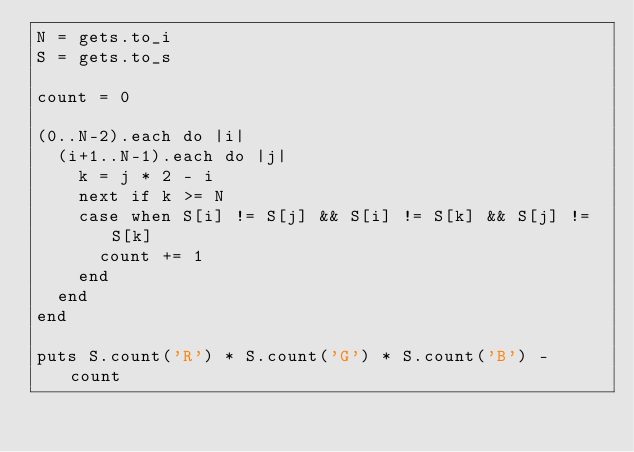Convert code to text. <code><loc_0><loc_0><loc_500><loc_500><_Ruby_>N = gets.to_i
S = gets.to_s

count = 0

(0..N-2).each do |i|
  (i+1..N-1).each do |j|
    k = j * 2 - i
    next if k >= N
    case when S[i] != S[j] && S[i] != S[k] && S[j] != S[k]
      count += 1
    end
  end
end

puts S.count('R') * S.count('G') * S.count('B') - count</code> 